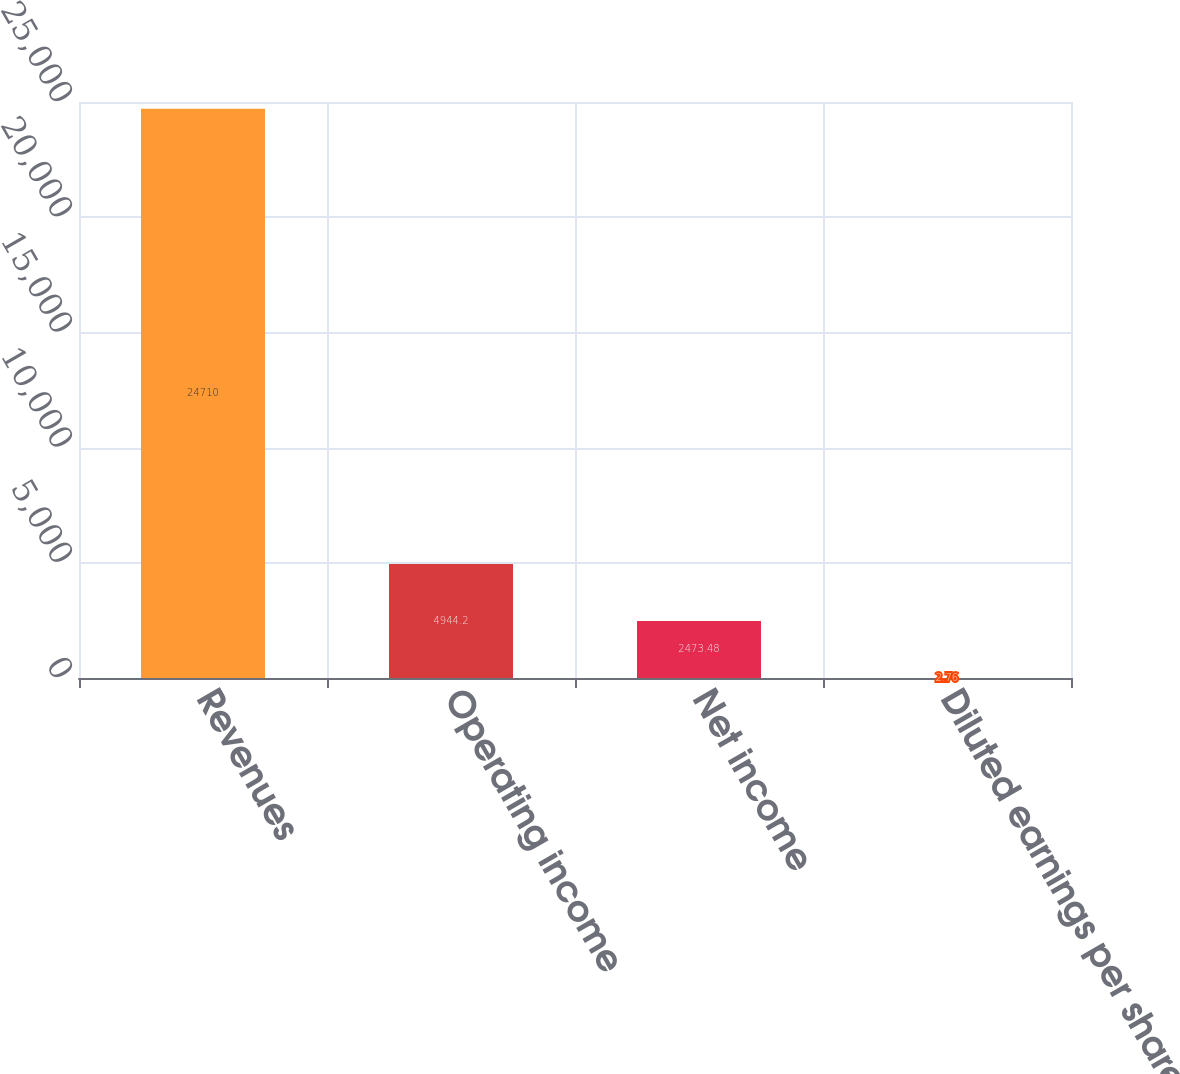Convert chart. <chart><loc_0><loc_0><loc_500><loc_500><bar_chart><fcel>Revenues<fcel>Operating income<fcel>Net income<fcel>Diluted earnings per share<nl><fcel>24710<fcel>4944.2<fcel>2473.48<fcel>2.76<nl></chart> 